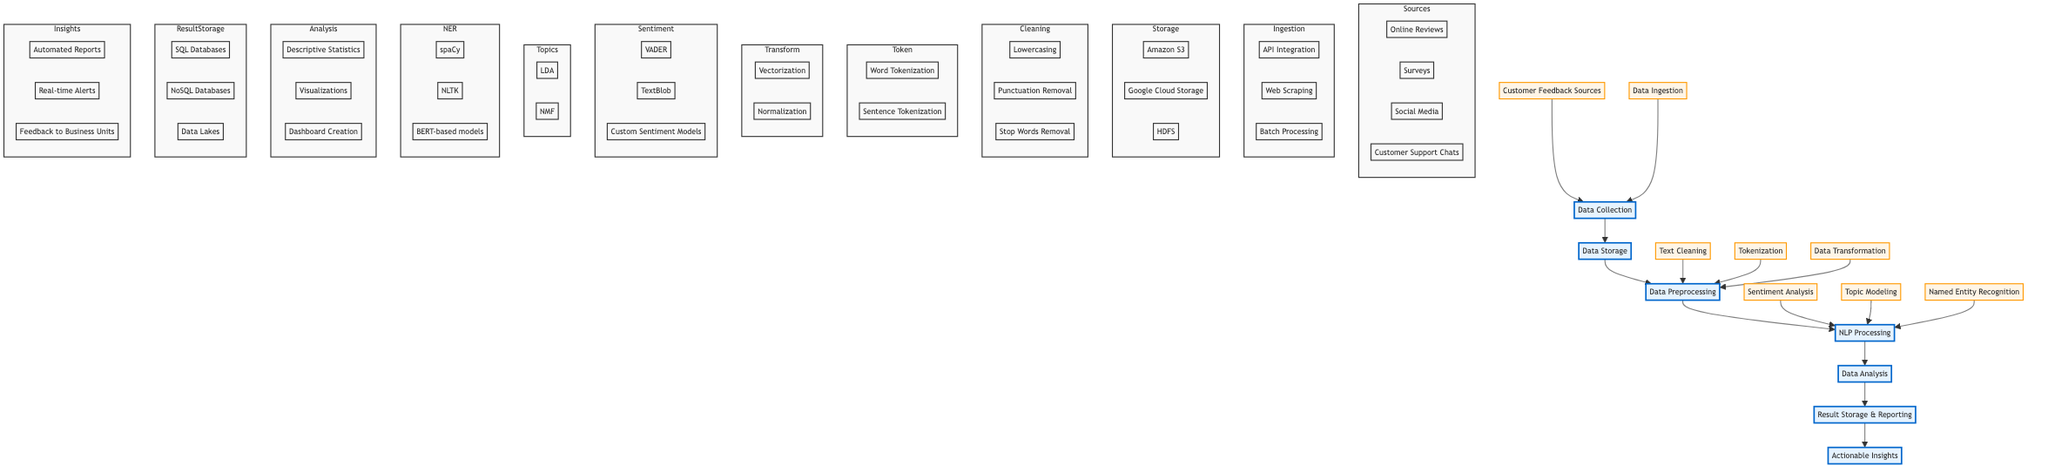What is the first stage in the data pipeline? The diagram indicates that the first stage in the data pipeline is "Data Collection." This is the starting point from where all data processing begins.
Answer: Data Collection How many components are listed under "Data Storage"? In the diagram, "Data Storage" has three components listed: Amazon S3, Google Cloud Storage, and HDFS. This can be counted directly from the diagram.
Answer: Three Which process follows "Data Preprocessing"? The diagram shows a direct flow from "Data Preprocessing" to "NLP Processing." Since the arrows connect these two nodes, it indicates that NLP Processing is the subsequent process.
Answer: NLP Processing Name one technique used in "Text Cleaning." Within the "Text Cleaning" subelement, there are three techniques: Lowercasing, Punctuation Removal, and Stop Words Removal. Any of these could be given as a valid answer, but one is requested.
Answer: Lowercasing What kind of analysis is performed after NLP Processing? According to the diagram, after NLP Processing comes "Data Analysis." This indicates that data analysis follows once NLP tasks are completed.
Answer: Data Analysis Which Natural Language Processing component has the highest count of techniques? Looking at the NLP Processing node, the "Sentiment Analysis" component has three techniques listed (VADER, TextBlob, and Custom Sentiment Models). Therefore, it has the highest count compared to others.
Answer: Sentiment Analysis What are the components stored under "Result Storage & Reporting"? The diagram categorizes "Result Storage & Reporting" into three components: SQL Databases, NoSQL Databases, and Data Lakes. Each of these functions stores results and facilitates reporting.
Answer: SQL Databases, NoSQL Databases, Data Lakes Which feedback mechanism is included in "Actionable Insights"? The "Actionable Insights" node includes three components, one of which is "Feedback to Business Units." This indicates that feedback is part of the insights generated for business operations.
Answer: Feedback to Business Units What is the primary data collection method mentioned in the "Customer Feedback Sources"? Under "Customer Feedback Sources," multiple methods are present, including Online Reviews, Surveys, Social Media, and Customer Support Chats. One primary method refers to any one of these, but as per selection, "Online Reviews" can be mentioned specifically.
Answer: Online Reviews 